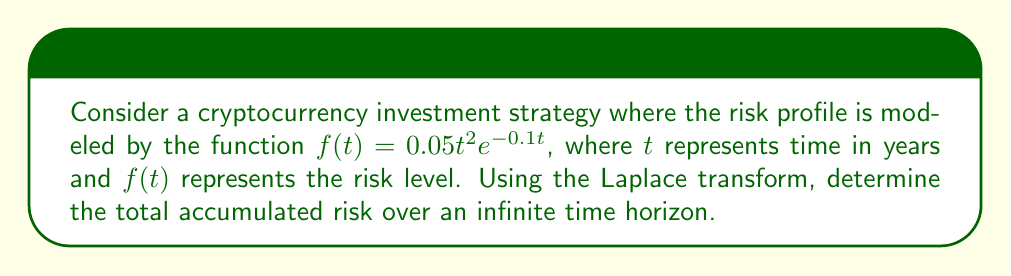Can you answer this question? To solve this problem, we'll use the Laplace transform to analyze the risk profile over an infinite time horizon. Let's break it down step-by-step:

1) The Laplace transform of $f(t)$ is defined as:

   $$F(s) = \int_0^\infty f(t)e^{-st}dt$$

2) Substituting our function $f(t) = 0.05t^2e^{-0.1t}$:

   $$F(s) = 0.05\int_0^\infty t^2e^{-0.1t}e^{-st}dt$$

3) Simplify the exponent:

   $$F(s) = 0.05\int_0^\infty t^2e^{-(s+0.1)t}dt$$

4) This integral is of the form $\int_0^\infty t^ne^{-at}dt$, which has a known solution:

   $$\int_0^\infty t^ne^{-at}dt = \frac{n!}{a^{n+1}}$$

5) In our case, $n=2$ and $a = s+0.1$. Applying this:

   $$F(s) = 0.05 \cdot \frac{2!}{(s+0.1)^3}$$

6) Simplify:

   $$F(s) = \frac{0.1}{(s+0.1)^3}$$

7) The total accumulated risk over an infinite time horizon is given by:

   $$\text{Total Risk} = \lim_{s \to 0} F(s)$$

8) Applying this limit:

   $$\text{Total Risk} = \lim_{s \to 0} \frac{0.1}{(s+0.1)^3} = \frac{0.1}{(0.1)^3} = 100$$

Therefore, the total accumulated risk over an infinite time horizon is 100.
Answer: 100 